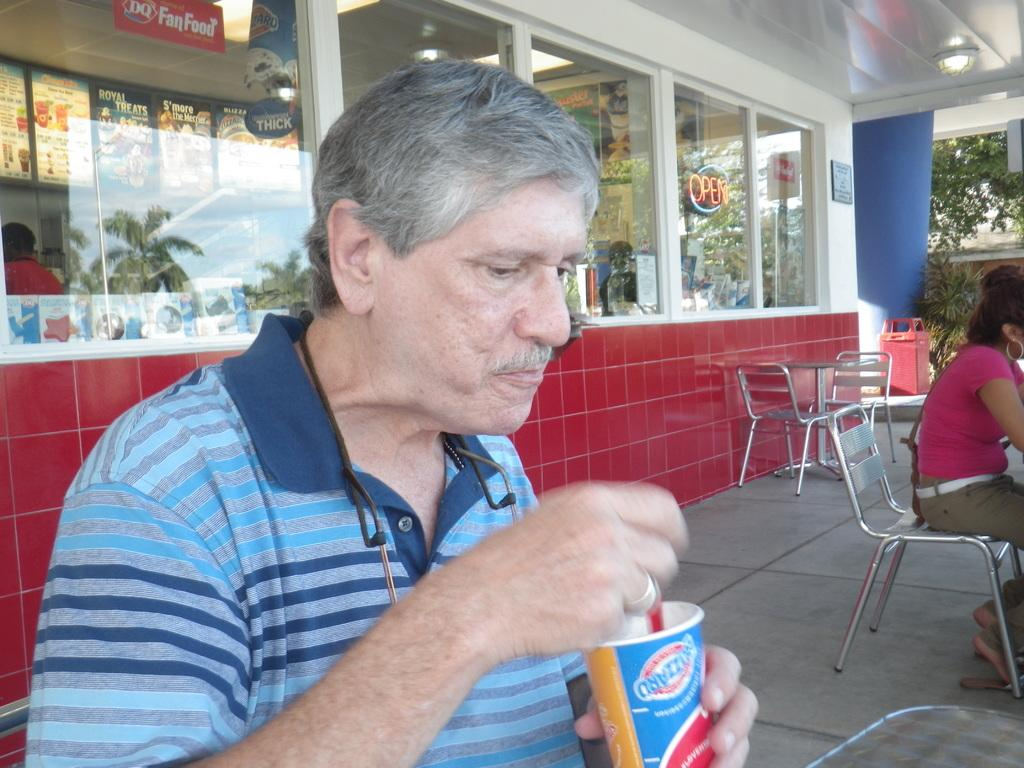What are the people in the image doing? The people in the image are sitting on chairs. Can you describe what one person is holding? One person is holding a cup. What else can be seen in the background of the image? There are additional chairs and a tree visible in the background of the image. What type of structure is visible in the background? There is a building in the background of the image. What type of writing can be seen on the chairs in the image? There is no writing visible on the chairs in the image. Can you describe the ant crawling on the person's shoulder in the image? There is no ant present in the image; it only features people sitting on chairs and a cup. 